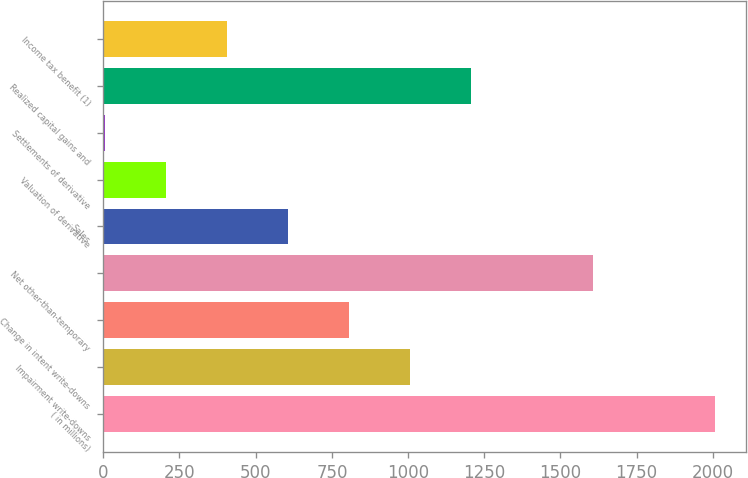Convert chart to OTSL. <chart><loc_0><loc_0><loc_500><loc_500><bar_chart><fcel>( in millions)<fcel>Impairment write-downs<fcel>Change in intent write-downs<fcel>Net other-than-temporary<fcel>Sales<fcel>Valuation of derivative<fcel>Settlements of derivative<fcel>Realized capital gains and<fcel>Income tax benefit (1)<nl><fcel>2007<fcel>1006.5<fcel>806.4<fcel>1606.8<fcel>606.3<fcel>206.1<fcel>6<fcel>1206.6<fcel>406.2<nl></chart> 